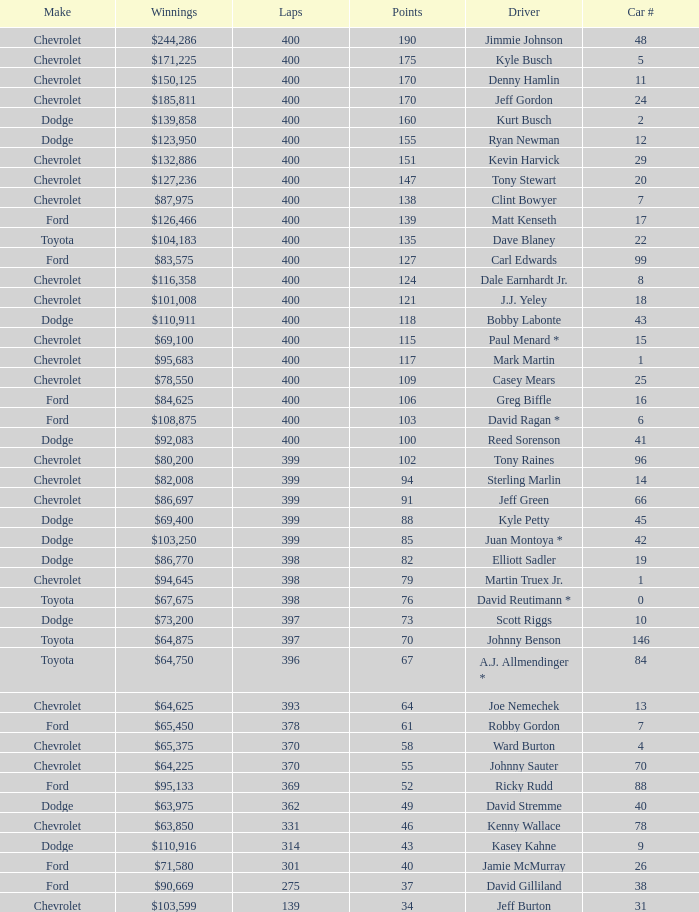What were the winnings for the Chevrolet with a number larger than 29 and scored 102 points? $80,200. 